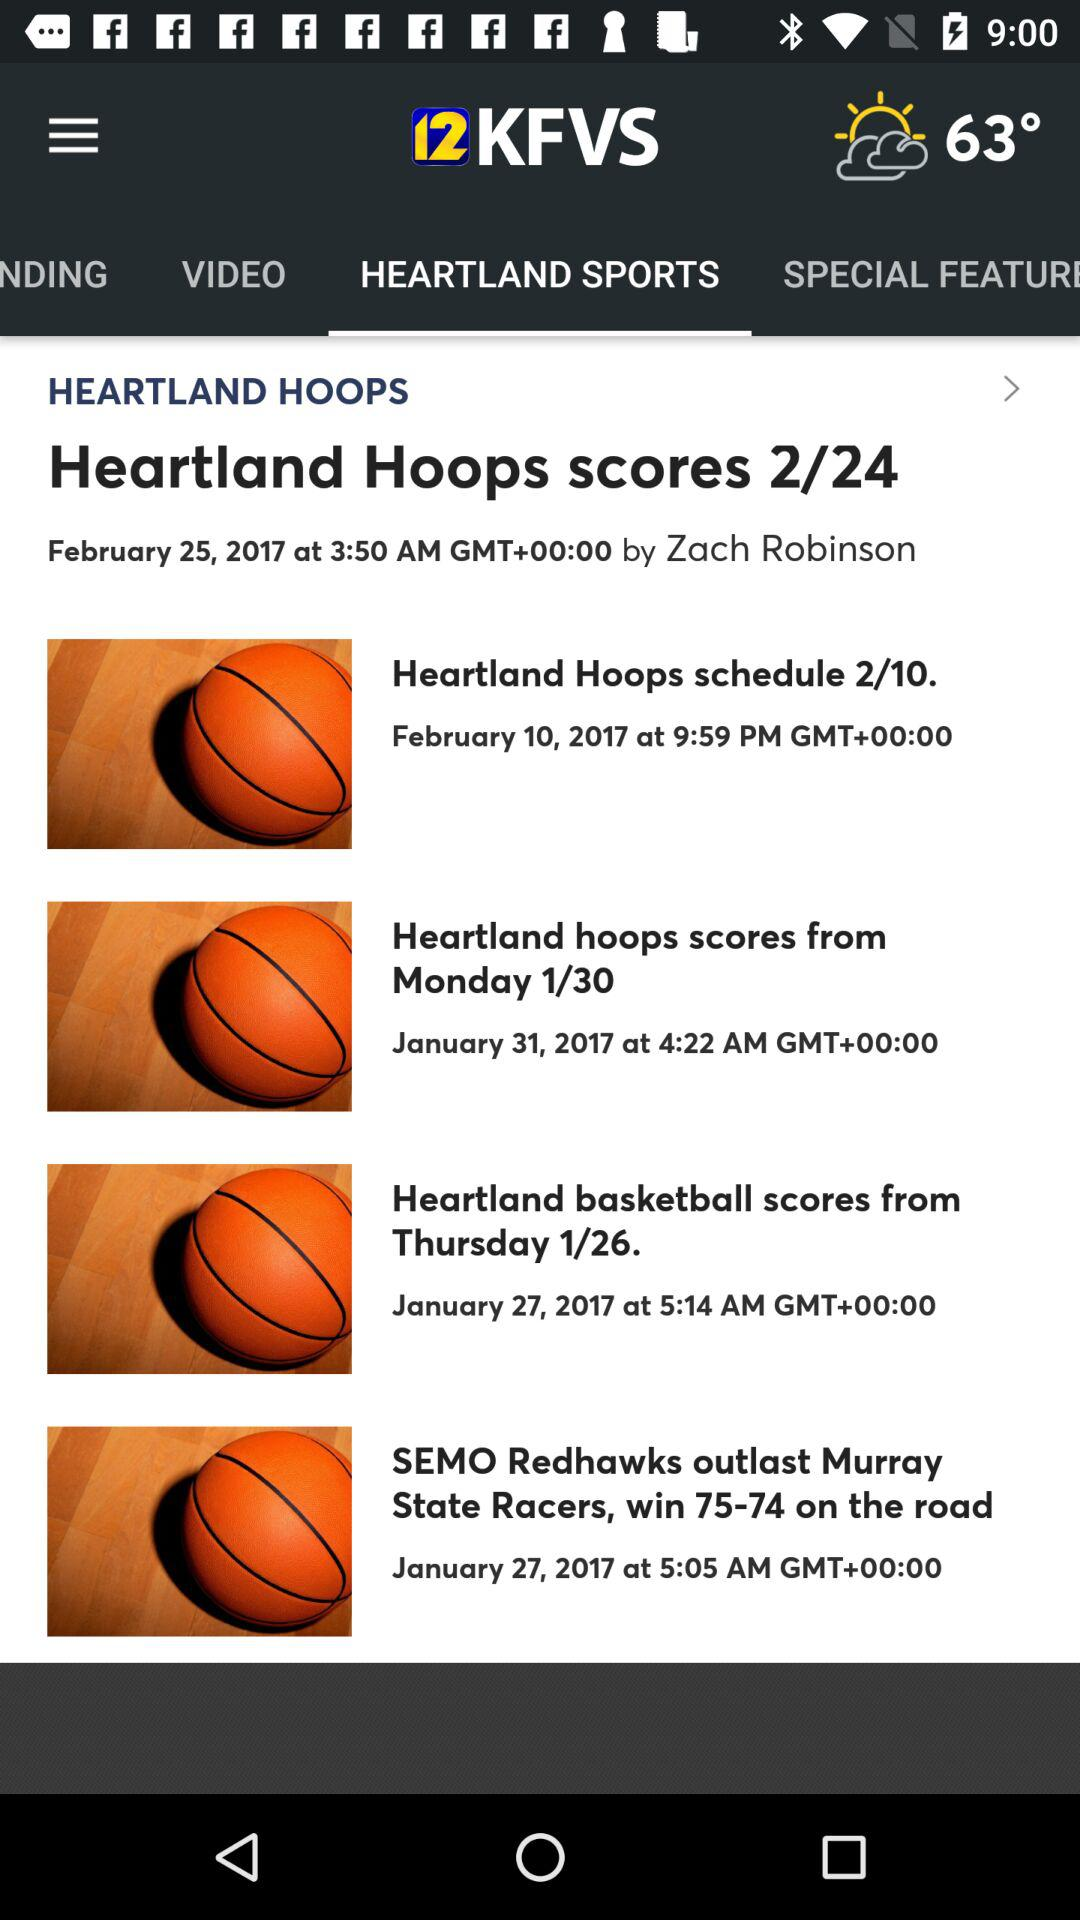What is the score of game on thursday?
When the provided information is insufficient, respond with <no answer>. <no answer> 